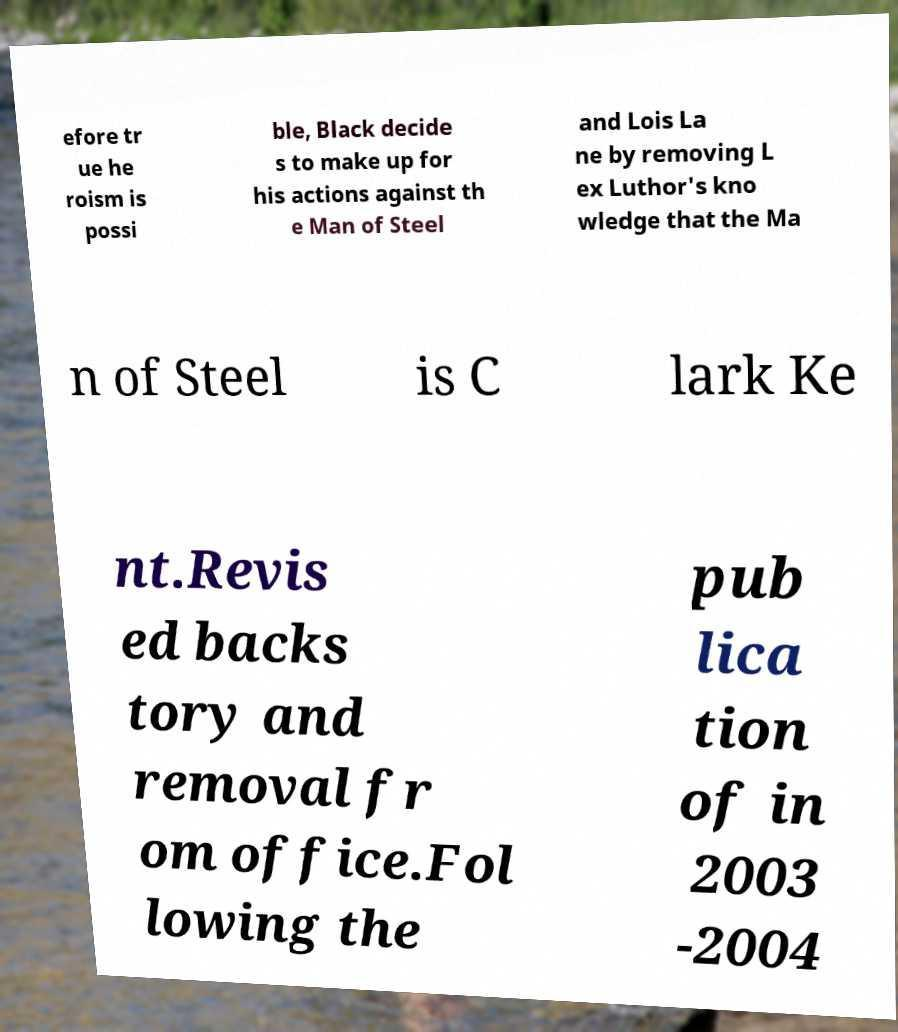Could you assist in decoding the text presented in this image and type it out clearly? efore tr ue he roism is possi ble, Black decide s to make up for his actions against th e Man of Steel and Lois La ne by removing L ex Luthor's kno wledge that the Ma n of Steel is C lark Ke nt.Revis ed backs tory and removal fr om office.Fol lowing the pub lica tion of in 2003 -2004 